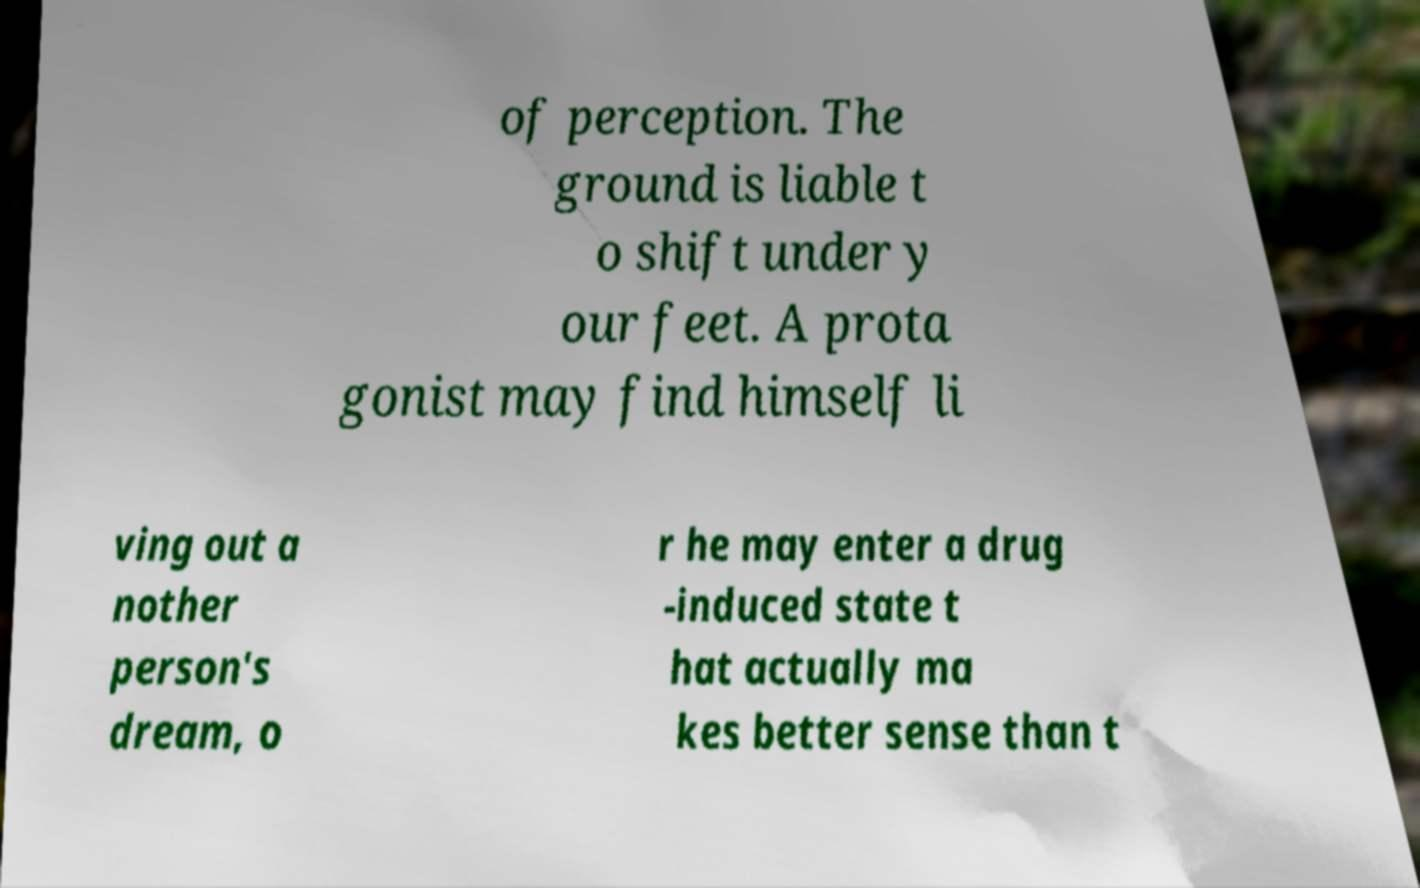Could you assist in decoding the text presented in this image and type it out clearly? of perception. The ground is liable t o shift under y our feet. A prota gonist may find himself li ving out a nother person's dream, o r he may enter a drug -induced state t hat actually ma kes better sense than t 